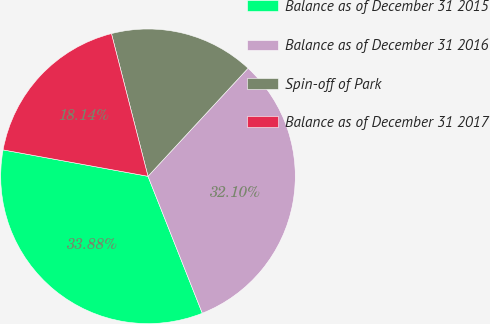Convert chart. <chart><loc_0><loc_0><loc_500><loc_500><pie_chart><fcel>Balance as of December 31 2015<fcel>Balance as of December 31 2016<fcel>Spin-off of Park<fcel>Balance as of December 31 2017<nl><fcel>33.88%<fcel>32.1%<fcel>15.88%<fcel>18.14%<nl></chart> 